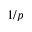Convert formula to latex. <formula><loc_0><loc_0><loc_500><loc_500>1 / p</formula> 